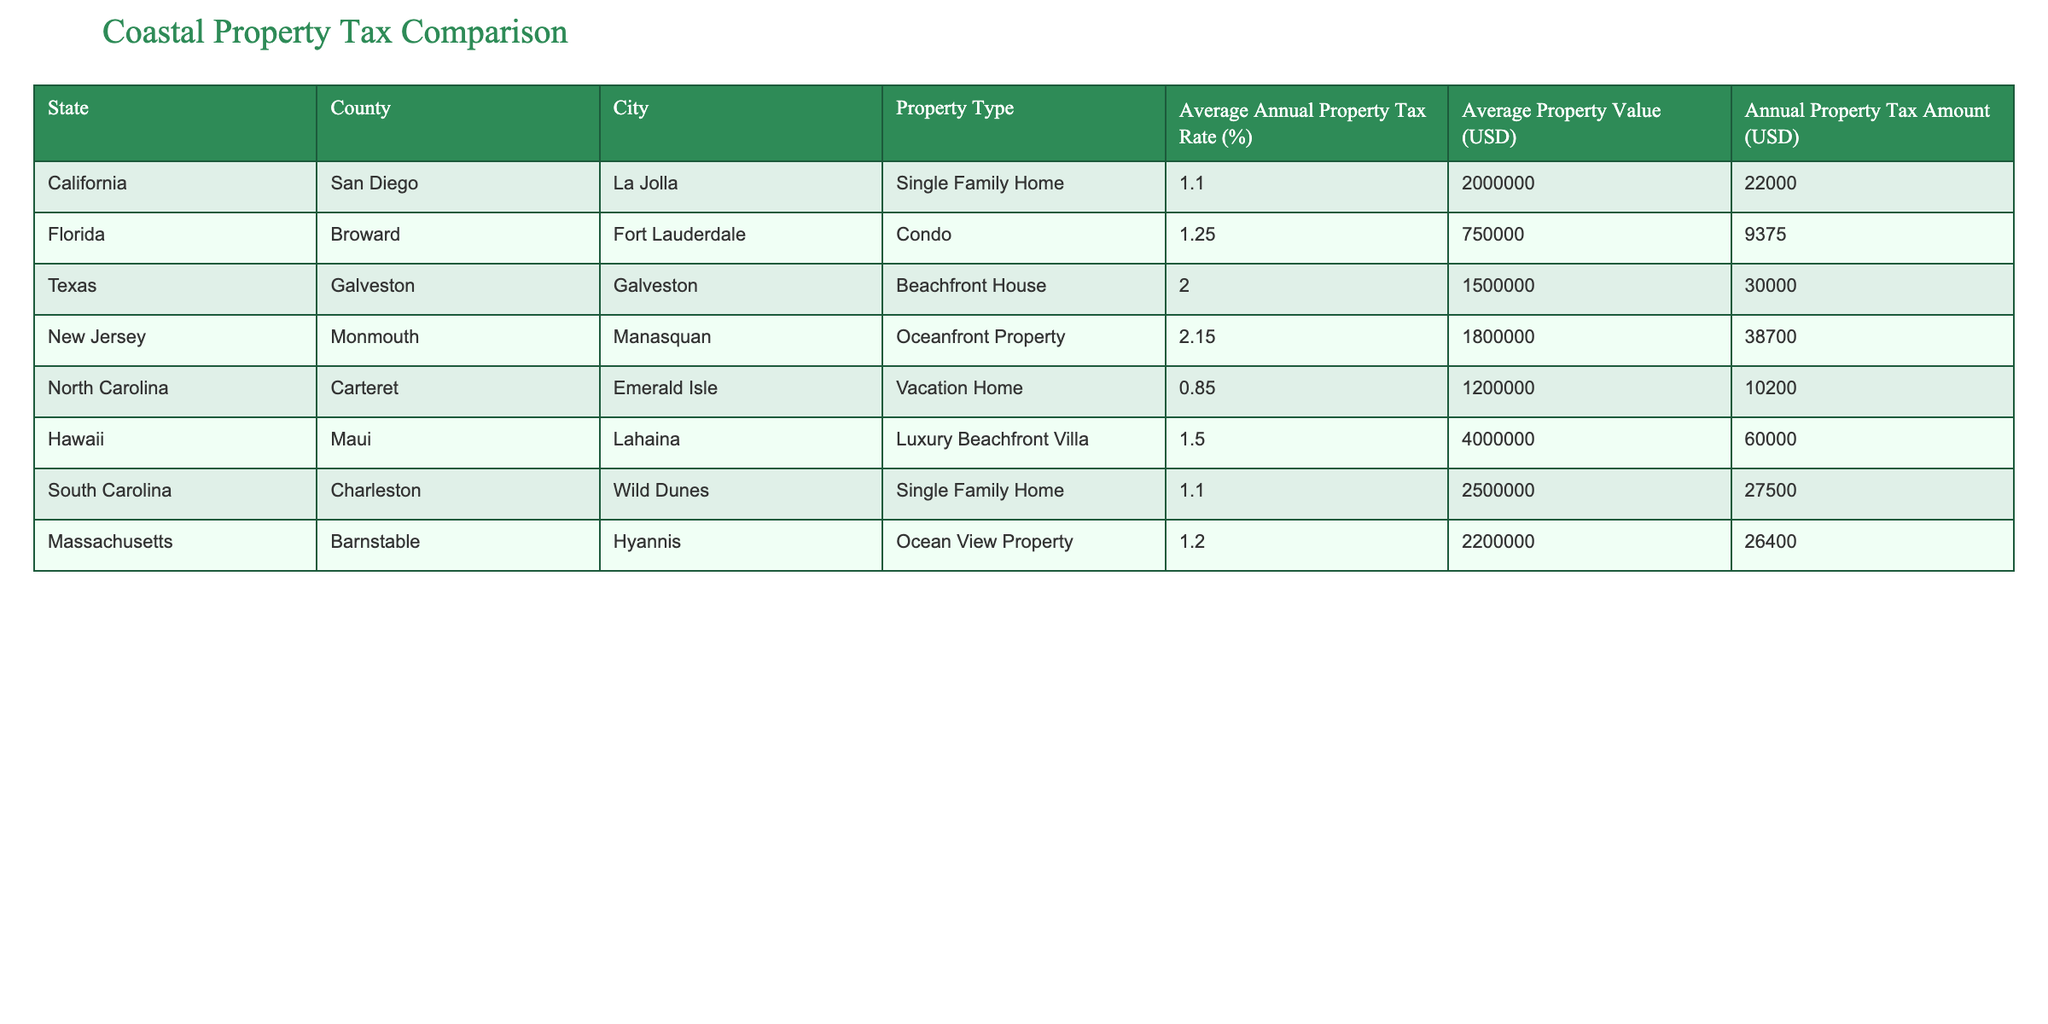What is the property type with the highest average annual property tax rate? The highest average annual property tax rate can be found by comparing the values in the "Average Annual Property Tax Rate (%)" column. Scanning through the table, we see that the Oceanfront Property in New Jersey has a rate of 2.15%, which is the highest compared to the other property types listed.
Answer: Oceanfront Property Which state has the lowest average property tax amount? To find the lowest average property tax amount, we can look at the "Annual Property Tax Amount (USD)" column and identify the smallest value. The Vacation Home in North Carolina has an annual tax amount of 10,200 USD, which is the lowest among all the entries.
Answer: North Carolina Calculate the average annual property tax amount of all properties listed in the table. First, sum up the annual property tax amounts: 22,000 + 9,375 + 30,000 + 38,700 + 10,200 + 60,000 + 27,500 + 26,400 = 224,175. There are 8 properties in total, so we divide 224,175 by 8 to find the average: 224,175 / 8 = 28,021.875, which can be rounded to 28,022 USD.
Answer: 28,022 USD Is there a beachfront property listed in Florida? Looking through the cities and property types in the table, we notice that Fort Lauderdale is listed under Florida, but its property type is a Condo, not a beachfront property. Therefore, there is no beachfront property in Florida as defined by this table.
Answer: No Which city has the highest average property value? To determine which city has the highest average property value, we need to check the "Average Property Value (USD)" column. The Luxury Beachfront Villa in Maui, Hawaii has the highest value at 4,000,000 USD, surpassing all others.
Answer: Lahaina What is the average annual property tax rate for properties in California? The two properties listed for California (La Jolla) have an average annual property tax rate of 1.1%. To compute the average, since both properties share the same rate, we can state that the average for California properties is simply 1.1%.
Answer: 1.1% How much higher is the average annual property tax amount for Oceanfront Property compared to Vacation Home? The average annual property tax amount for Oceanfront Property in New Jersey is 38,700 USD, while the Vacation Home in North Carolina has a tax amount of 10,200 USD. The difference is calculated as 38,700 - 10,200 = 28,500 USD. Therefore, the Oceanfront Property has a tax amount that is 28,500 USD higher.
Answer: 28,500 USD Is the average property value for the properties in South Carolina higher than 2 million USD? The average property value for the property in South Carolina (Wild Dunes) is 2,500,000 USD. Since this value exceeds 2 million USD, we conclude that the statement is true.
Answer: Yes 